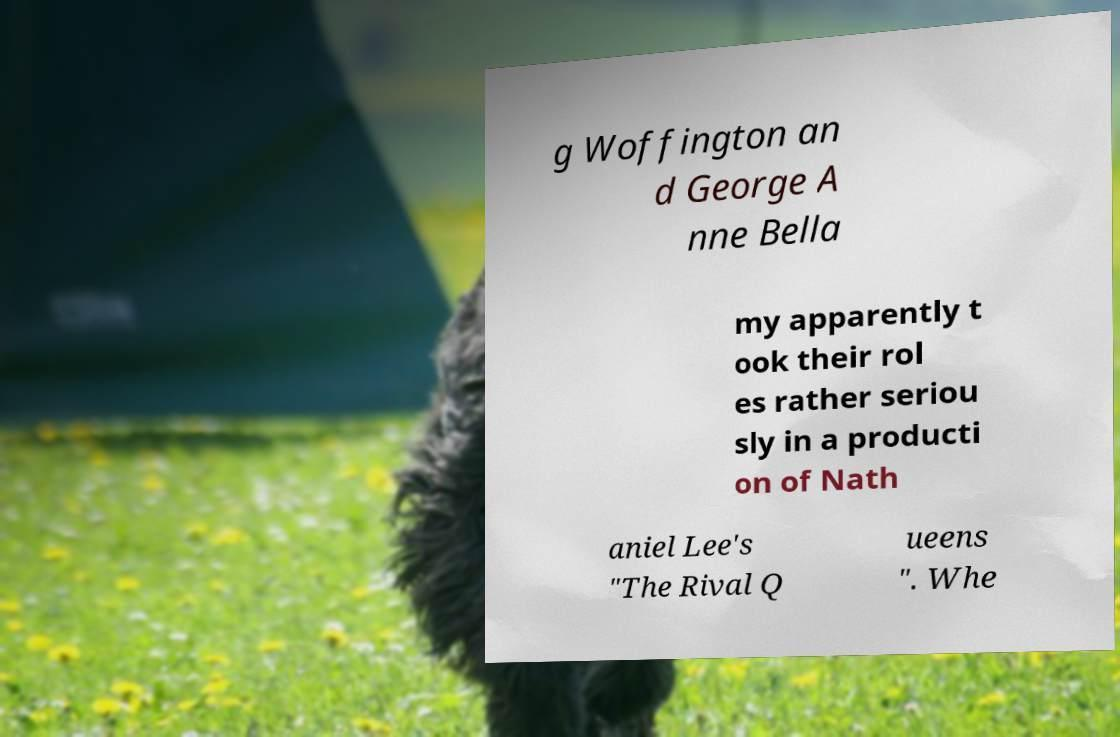Could you extract and type out the text from this image? g Woffington an d George A nne Bella my apparently t ook their rol es rather seriou sly in a producti on of Nath aniel Lee's "The Rival Q ueens ". Whe 